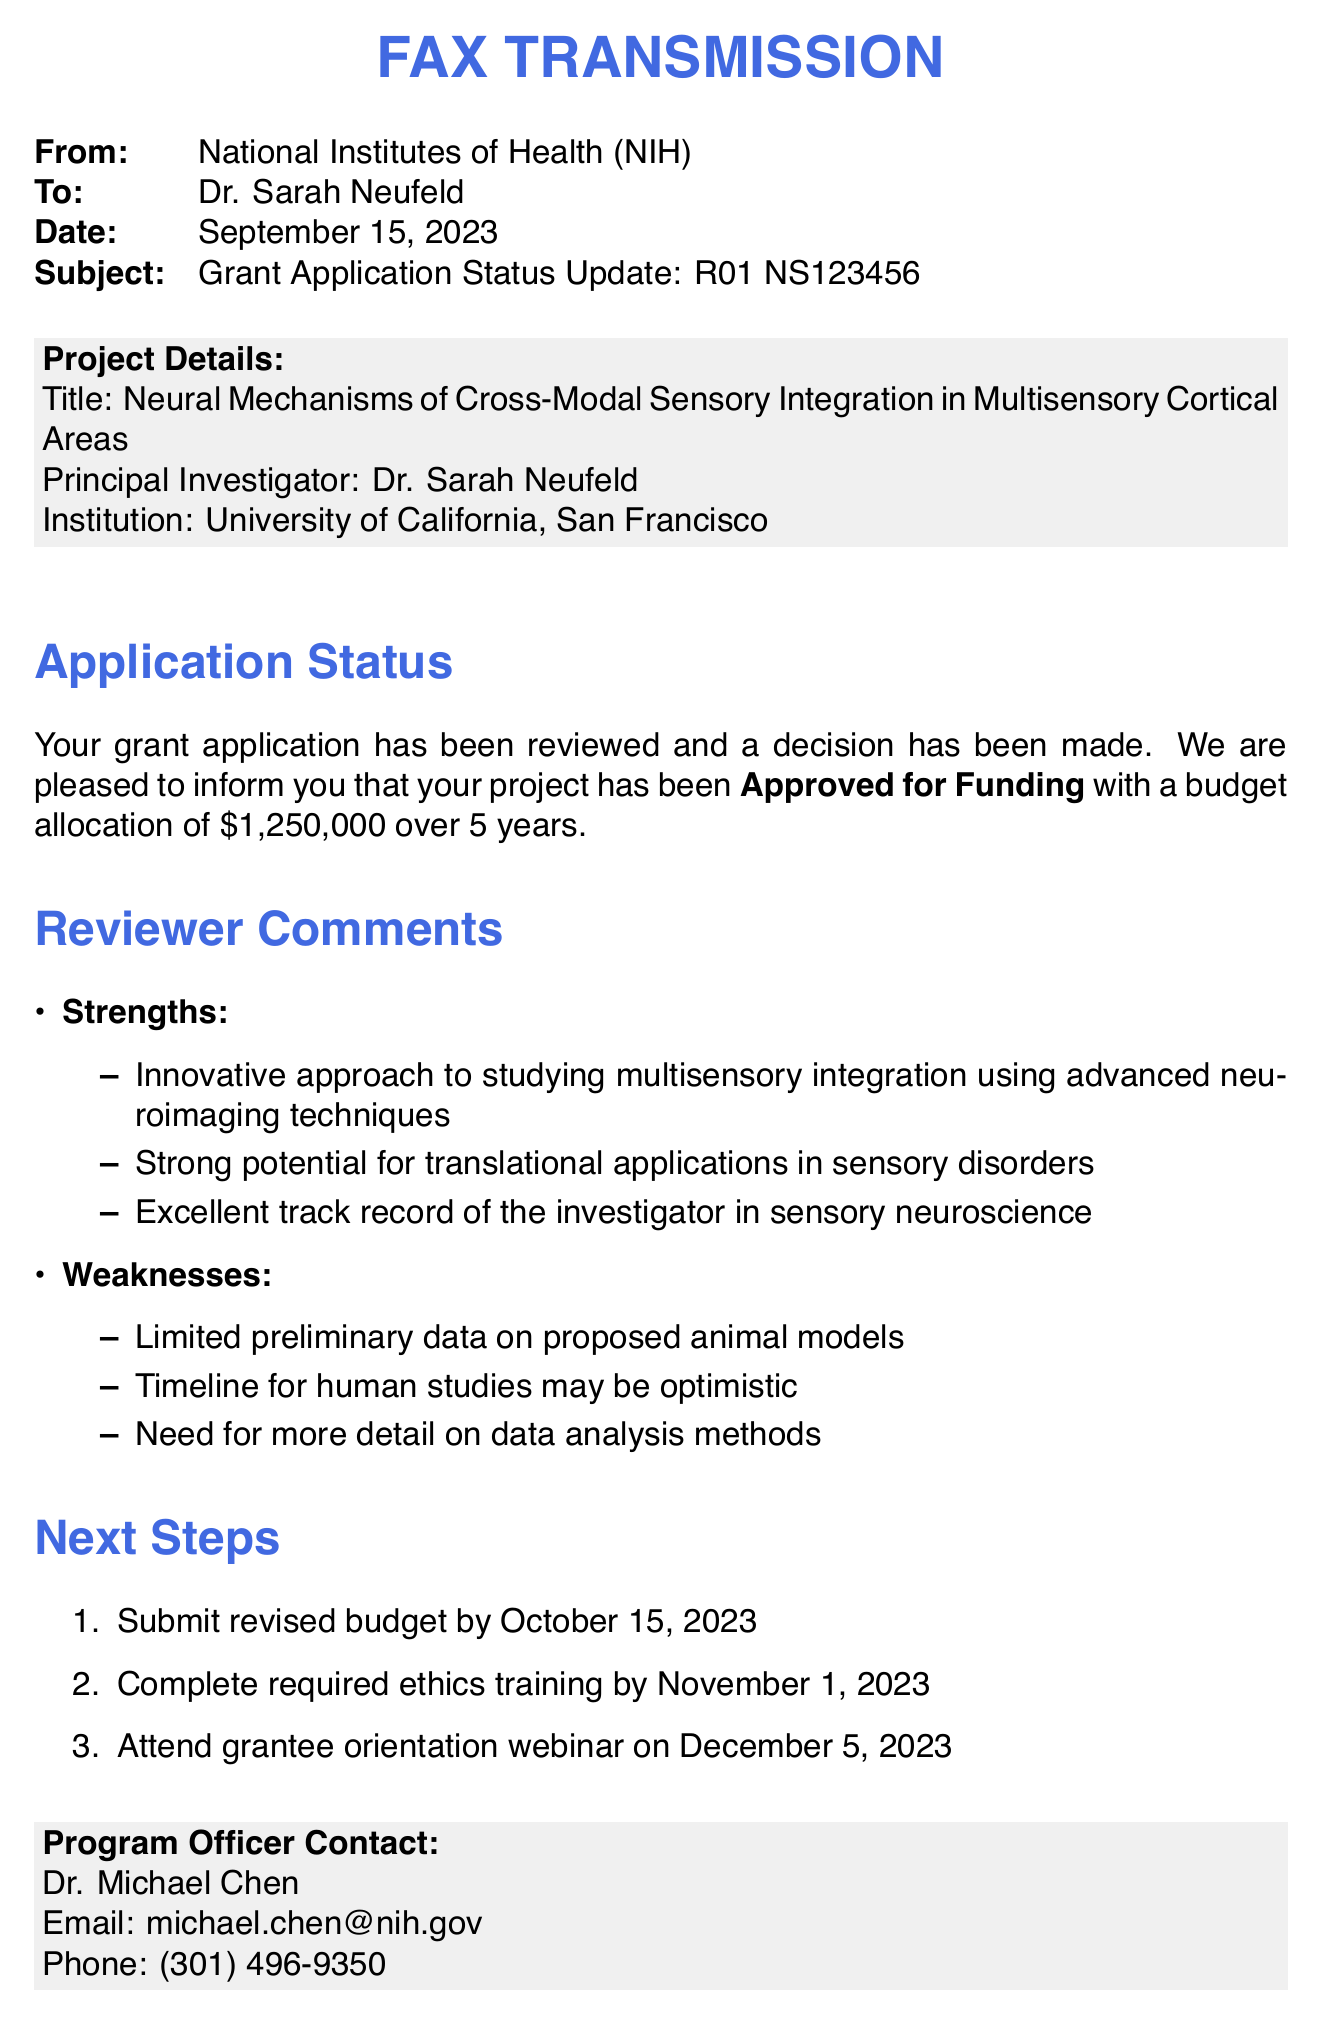What is the grant application number? The grant application number is specified in the document and is R01 NS123456.
Answer: R01 NS123456 What is the total funding allocated for the project? The total funding allocated for the project is indicated as $1,250,000 over five years.
Answer: $1,250,000 Who is the Principal Investigator of the project? The Principal Investigator is named in the document as Dr. Sarah Neufeld.
Answer: Dr. Sarah Neufeld What is one of the strengths noted by the reviewers? The document contains strengths noted by the reviewers, one of which is an innovative approach to studying multisensory integration.
Answer: Innovative approach to studying multisensory integration What is the deadline for submitting the revised budget? The deadline for submitting the revised budget is mentioned as October 15, 2023.
Answer: October 15, 2023 What aspect of the preliminary data is considered a weakness? One of the weaknesses noted regarding preliminary data is the limited preliminary data on proposed animal models.
Answer: Limited preliminary data on proposed animal models Who is the contact person for the program? The contact person for the program is specified as Dr. Michael Chen.
Answer: Dr. Michael Chen What is the date of the grantee orientation webinar? The date for the grantee orientation webinar is stated as December 5, 2023.
Answer: December 5, 2023 